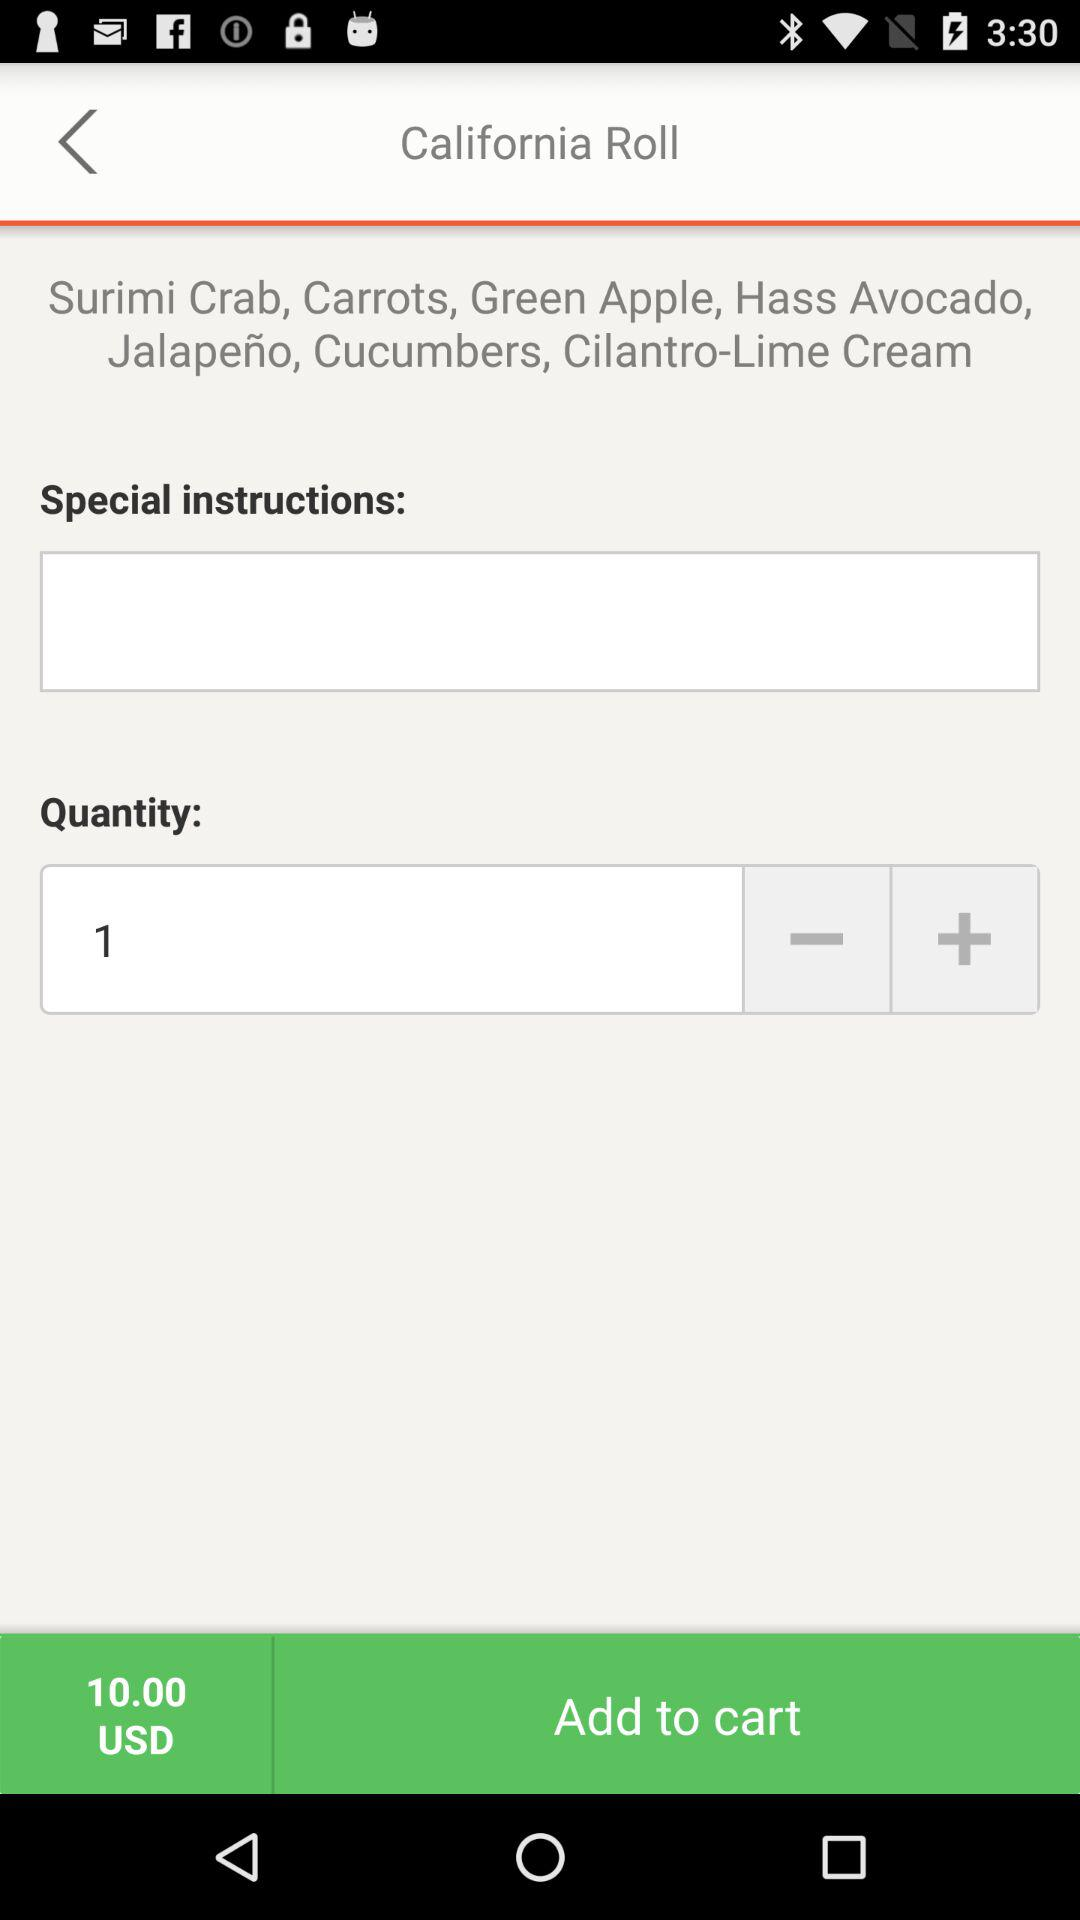What are the grocery items available on the screen? The items are Surimi Crab, Carrots, Green Apple, Hass Avocado, Jalapeño, Cucumbers and Cilantro-Lime Cream. 